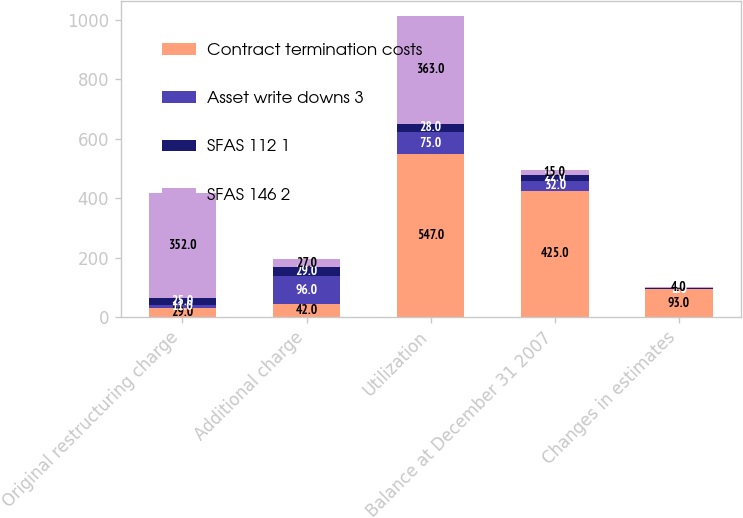<chart> <loc_0><loc_0><loc_500><loc_500><stacked_bar_chart><ecel><fcel>Original restructuring charge<fcel>Additional charge<fcel>Utilization<fcel>Balance at December 31 2007<fcel>Changes in estimates<nl><fcel>Contract termination costs<fcel>29<fcel>42<fcel>547<fcel>425<fcel>93<nl><fcel>Asset write downs 3<fcel>11<fcel>96<fcel>75<fcel>32<fcel>2<nl><fcel>SFAS 112 1<fcel>25<fcel>29<fcel>28<fcel>22<fcel>2<nl><fcel>SFAS 146 2<fcel>352<fcel>27<fcel>363<fcel>15<fcel>4<nl></chart> 